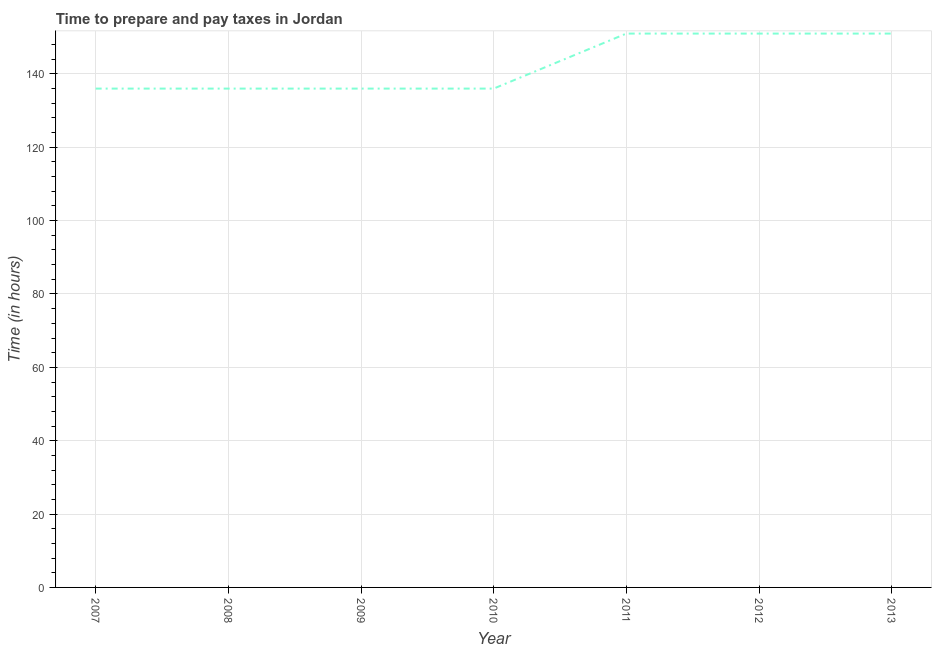What is the time to prepare and pay taxes in 2009?
Provide a short and direct response. 136. Across all years, what is the maximum time to prepare and pay taxes?
Provide a succinct answer. 151. Across all years, what is the minimum time to prepare and pay taxes?
Your answer should be compact. 136. What is the sum of the time to prepare and pay taxes?
Keep it short and to the point. 997. What is the difference between the time to prepare and pay taxes in 2008 and 2011?
Provide a short and direct response. -15. What is the average time to prepare and pay taxes per year?
Keep it short and to the point. 142.43. What is the median time to prepare and pay taxes?
Provide a short and direct response. 136. In how many years, is the time to prepare and pay taxes greater than 12 hours?
Provide a succinct answer. 7. What is the ratio of the time to prepare and pay taxes in 2009 to that in 2013?
Your response must be concise. 0.9. What is the difference between the highest and the second highest time to prepare and pay taxes?
Keep it short and to the point. 0. Is the sum of the time to prepare and pay taxes in 2007 and 2011 greater than the maximum time to prepare and pay taxes across all years?
Provide a short and direct response. Yes. What is the difference between the highest and the lowest time to prepare and pay taxes?
Keep it short and to the point. 15. What is the difference between two consecutive major ticks on the Y-axis?
Give a very brief answer. 20. Does the graph contain grids?
Your answer should be very brief. Yes. What is the title of the graph?
Offer a terse response. Time to prepare and pay taxes in Jordan. What is the label or title of the Y-axis?
Make the answer very short. Time (in hours). What is the Time (in hours) in 2007?
Make the answer very short. 136. What is the Time (in hours) in 2008?
Your answer should be very brief. 136. What is the Time (in hours) in 2009?
Ensure brevity in your answer.  136. What is the Time (in hours) of 2010?
Offer a terse response. 136. What is the Time (in hours) of 2011?
Provide a short and direct response. 151. What is the Time (in hours) of 2012?
Offer a very short reply. 151. What is the Time (in hours) in 2013?
Your answer should be very brief. 151. What is the difference between the Time (in hours) in 2007 and 2009?
Your answer should be very brief. 0. What is the difference between the Time (in hours) in 2007 and 2010?
Your answer should be very brief. 0. What is the difference between the Time (in hours) in 2007 and 2011?
Your answer should be compact. -15. What is the difference between the Time (in hours) in 2008 and 2009?
Your response must be concise. 0. What is the difference between the Time (in hours) in 2008 and 2012?
Provide a succinct answer. -15. What is the difference between the Time (in hours) in 2008 and 2013?
Your response must be concise. -15. What is the difference between the Time (in hours) in 2009 and 2011?
Give a very brief answer. -15. What is the difference between the Time (in hours) in 2010 and 2012?
Make the answer very short. -15. What is the difference between the Time (in hours) in 2011 and 2013?
Make the answer very short. 0. What is the ratio of the Time (in hours) in 2007 to that in 2010?
Your response must be concise. 1. What is the ratio of the Time (in hours) in 2007 to that in 2011?
Your answer should be very brief. 0.9. What is the ratio of the Time (in hours) in 2007 to that in 2012?
Provide a succinct answer. 0.9. What is the ratio of the Time (in hours) in 2007 to that in 2013?
Keep it short and to the point. 0.9. What is the ratio of the Time (in hours) in 2008 to that in 2010?
Give a very brief answer. 1. What is the ratio of the Time (in hours) in 2008 to that in 2011?
Your answer should be compact. 0.9. What is the ratio of the Time (in hours) in 2008 to that in 2012?
Your response must be concise. 0.9. What is the ratio of the Time (in hours) in 2008 to that in 2013?
Provide a short and direct response. 0.9. What is the ratio of the Time (in hours) in 2009 to that in 2010?
Ensure brevity in your answer.  1. What is the ratio of the Time (in hours) in 2009 to that in 2011?
Offer a terse response. 0.9. What is the ratio of the Time (in hours) in 2009 to that in 2012?
Offer a terse response. 0.9. What is the ratio of the Time (in hours) in 2009 to that in 2013?
Give a very brief answer. 0.9. What is the ratio of the Time (in hours) in 2010 to that in 2011?
Give a very brief answer. 0.9. What is the ratio of the Time (in hours) in 2010 to that in 2012?
Offer a terse response. 0.9. What is the ratio of the Time (in hours) in 2010 to that in 2013?
Provide a succinct answer. 0.9. What is the ratio of the Time (in hours) in 2012 to that in 2013?
Your answer should be compact. 1. 